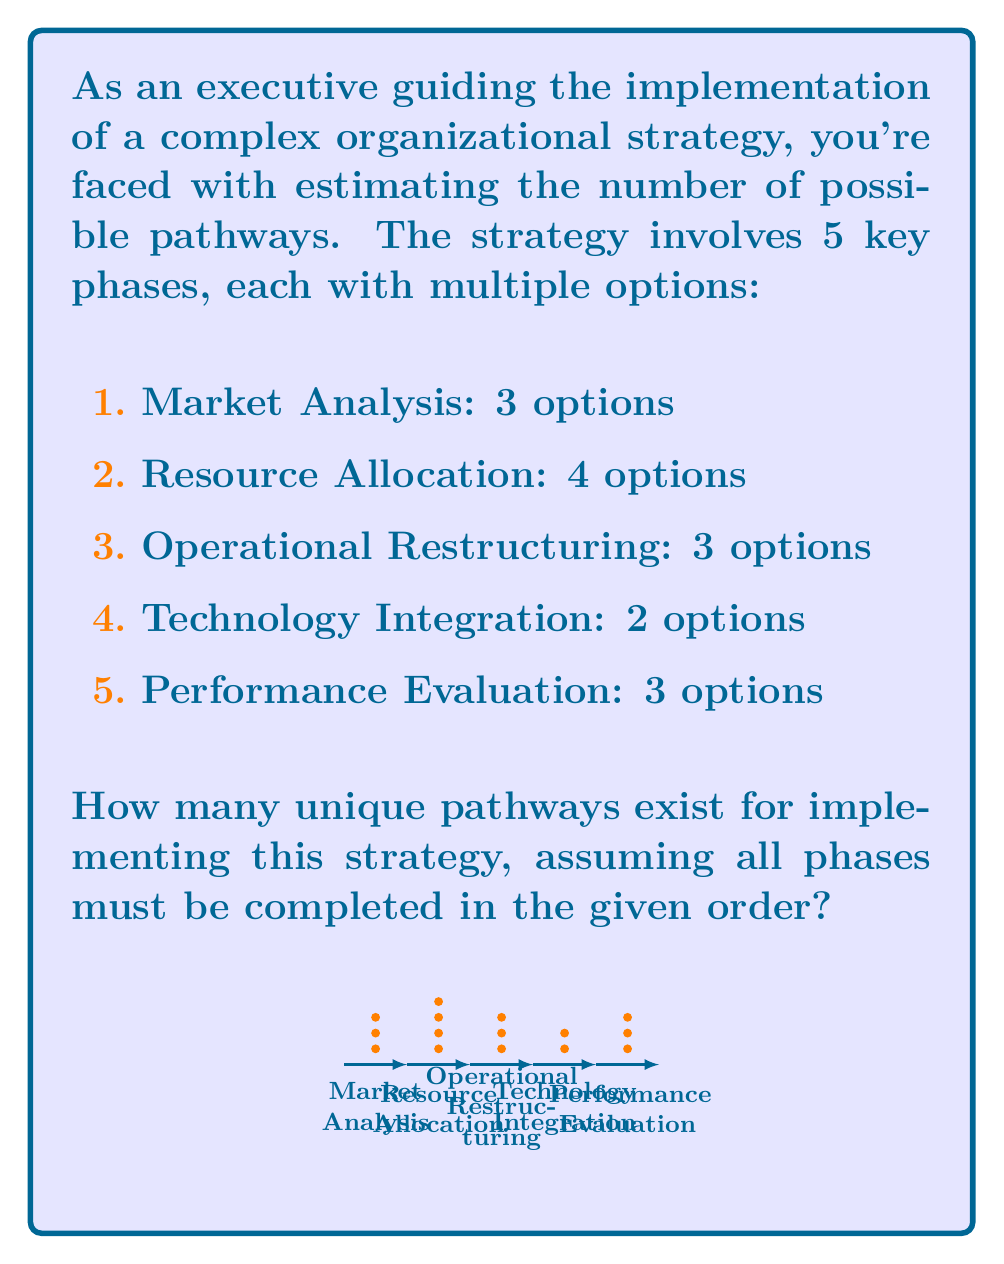What is the answer to this math problem? To solve this problem, we'll use the fundamental counting principle. This principle states that if we have a sequence of independent choices, the total number of possible outcomes is the product of the number of options for each choice.

Let's break it down step-by-step:

1) Market Analysis: 3 options
2) Resource Allocation: 4 options
3) Operational Restructuring: 3 options
4) Technology Integration: 2 options
5) Performance Evaluation: 3 options

Since each phase must be completed in order, and the choice in each phase is independent of the others, we multiply the number of options for each phase:

$$ \text{Total Pathways} = 3 \times 4 \times 3 \times 2 \times 3 $$

Calculating this:
$$ \text{Total Pathways} = 3 \times 4 \times 3 \times 2 \times 3 = 216 $$

Therefore, there are 216 unique pathways for implementing this complex organizational strategy.

This approach allows for quick estimation of implementation options, which is crucial for strategic planning and resource allocation in executive decision-making.
Answer: 216 pathways 